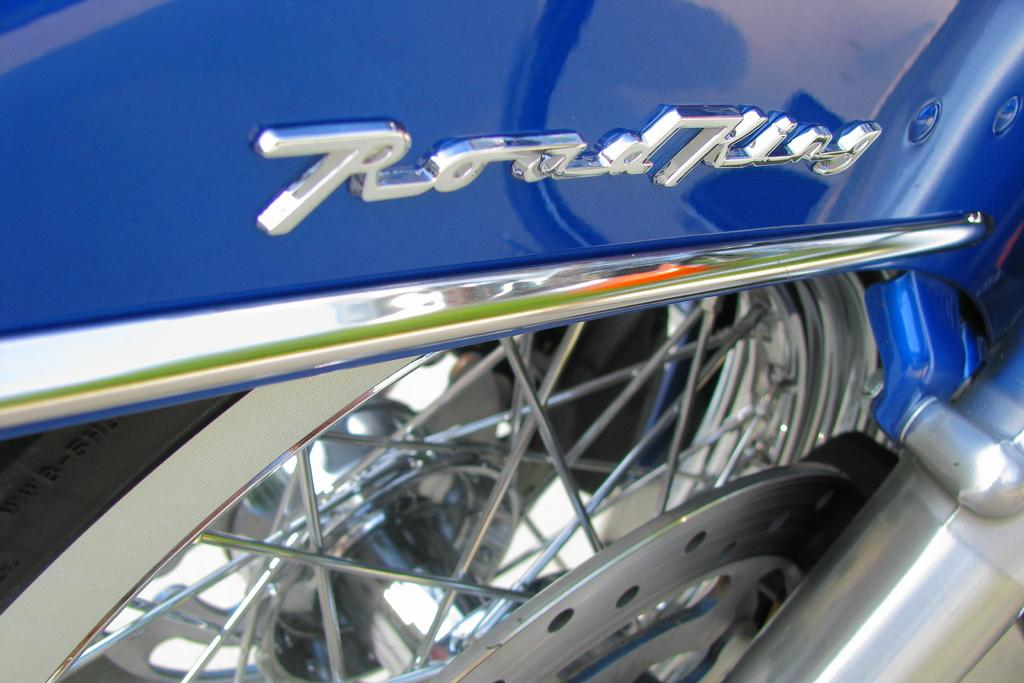What is the main subject of the image? The main subject of the image is a bike tire. Can you describe the level of detail in the image? The image contains a zoomed-in picture of the bike tire. What type of ink is used to draw the chess pieces on the bike tire in the image? There are no chess pieces or ink present in the image; it features a zoomed-in picture of a bike tire. How much toothpaste is visible on the bike tire in the image? There is no toothpaste present on the bike tire in the image. 